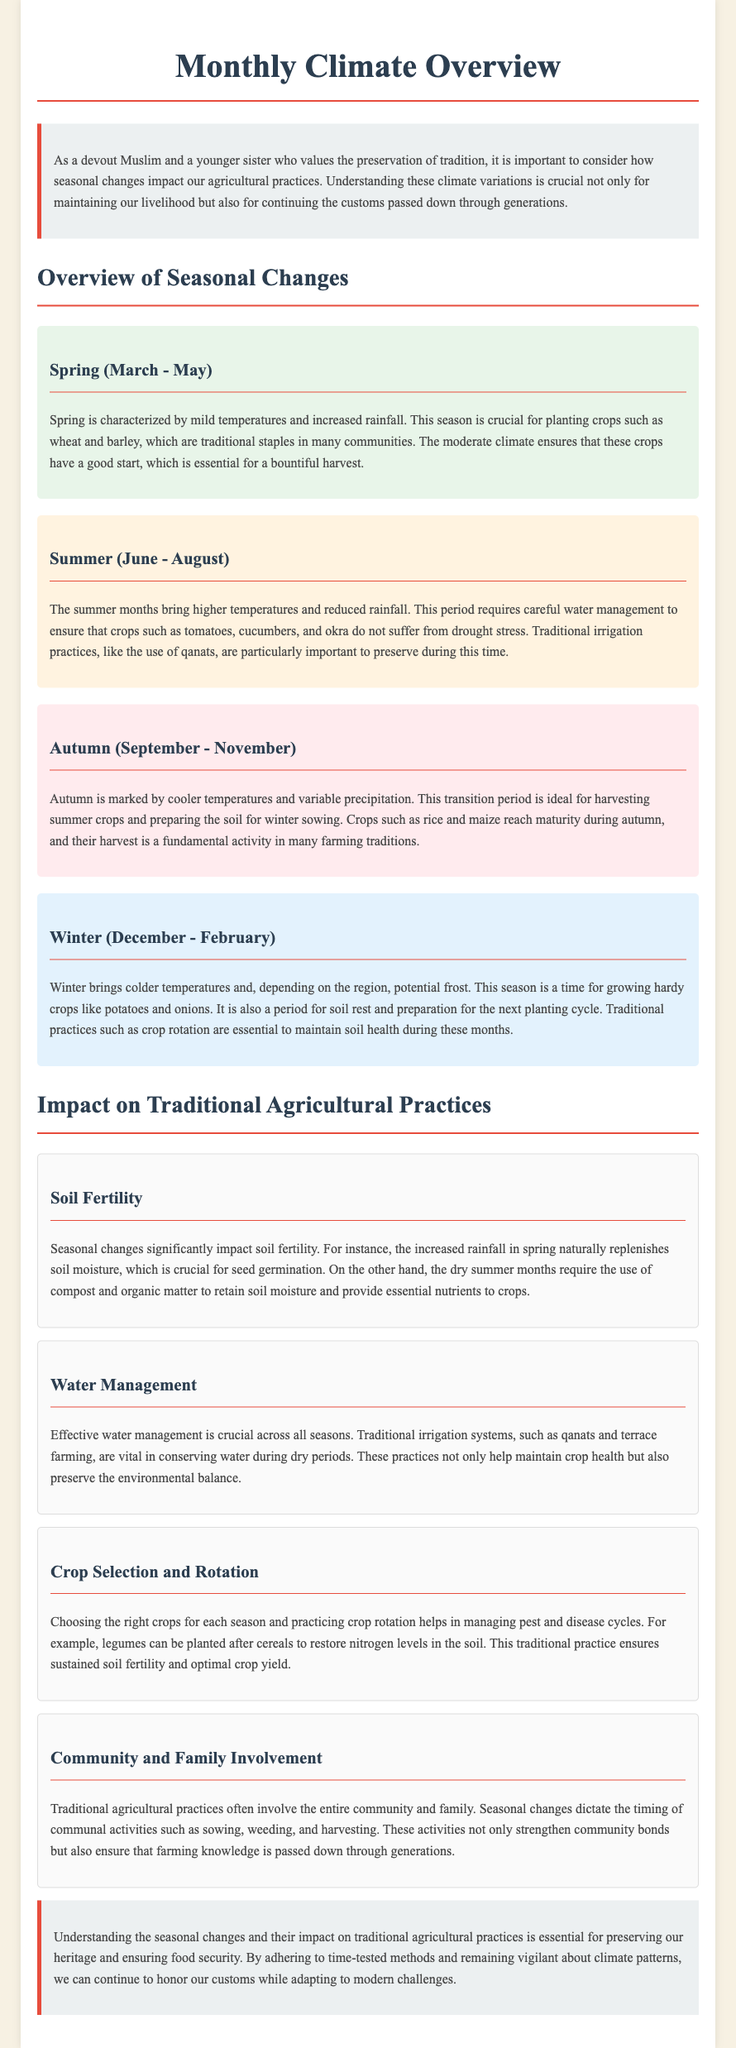what are the traditional staples planted in spring? The document states that crops such as wheat and barley are traditionally planted during spring.
Answer: wheat and barley which season is characterized by cooler temperatures and variable precipitation? The document indicates that autumn is marked by cooler temperatures and variable precipitation.
Answer: autumn what crops reach maturity during autumn? According to the text, crops such as rice and maize reach maturity in autumn.
Answer: rice and maize which period requires careful water management? The summer months are noted to require careful water management to prevent drought stress on crops.
Answer: summer what traditional practice is essential during winter for maintaining soil health? The document suggests that traditional practices like crop rotation are essential during winter for maintaining soil health.
Answer: crop rotation how does increased rainfall in spring affect soil? The document explains that increased rainfall in spring naturally replenishes soil moisture, which is crucial for seed germination.
Answer: replenishes soil moisture what is vital for conserving water during dry periods? The text emphasizes the importance of traditional irrigation systems, such as qanats, in conserving water during dry periods.
Answer: qanats which agricultural practice involves the entire community? The document points out that traditional agricultural practices often involve community and family participation during seasonal activities.
Answer: community involvement which season is ideal for planting crops like potatoes and onions? The document specifies that winter is the season for growing crops like potatoes and onions.
Answer: winter 